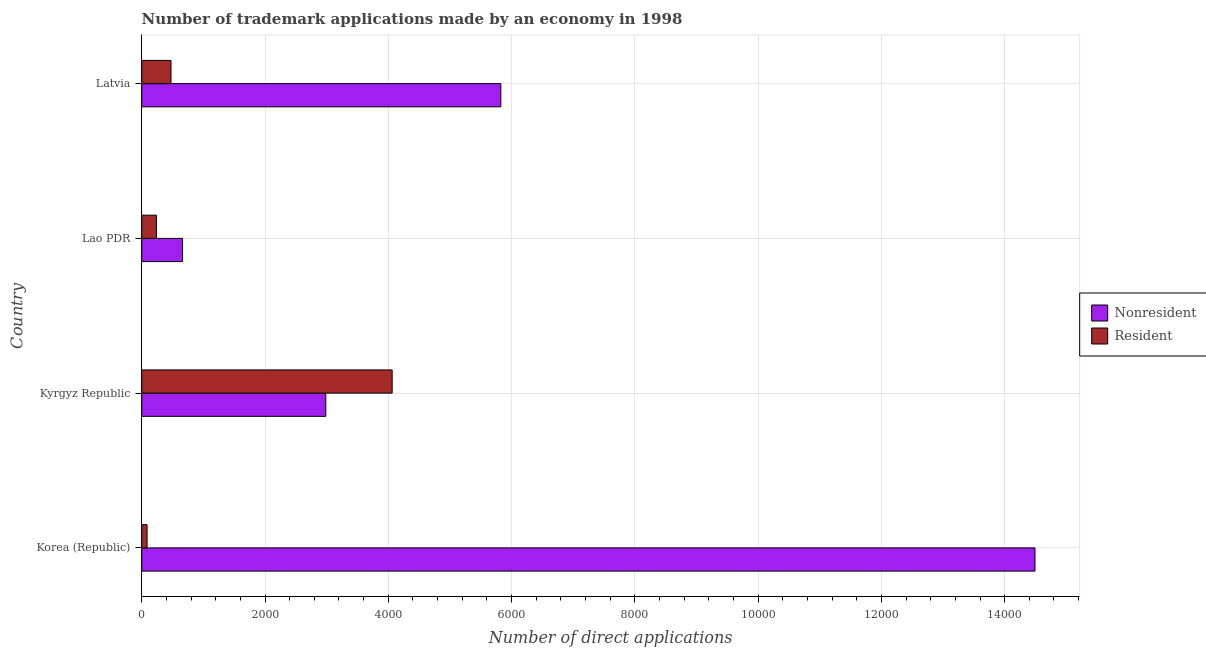How many groups of bars are there?
Offer a very short reply. 4. How many bars are there on the 1st tick from the bottom?
Give a very brief answer. 2. What is the label of the 2nd group of bars from the top?
Your answer should be compact. Lao PDR. In how many cases, is the number of bars for a given country not equal to the number of legend labels?
Make the answer very short. 0. What is the number of trademark applications made by residents in Lao PDR?
Offer a very short reply. 239. Across all countries, what is the maximum number of trademark applications made by residents?
Your answer should be compact. 4063. Across all countries, what is the minimum number of trademark applications made by non residents?
Give a very brief answer. 662. In which country was the number of trademark applications made by residents maximum?
Your response must be concise. Kyrgyz Republic. What is the total number of trademark applications made by residents in the graph?
Offer a terse response. 4864. What is the difference between the number of trademark applications made by non residents in Lao PDR and that in Latvia?
Your answer should be compact. -5164. What is the difference between the number of trademark applications made by residents in Latvia and the number of trademark applications made by non residents in Korea (Republic)?
Offer a very short reply. -1.40e+04. What is the average number of trademark applications made by residents per country?
Keep it short and to the point. 1216. What is the difference between the number of trademark applications made by non residents and number of trademark applications made by residents in Latvia?
Provide a short and direct response. 5351. In how many countries, is the number of trademark applications made by non residents greater than 9200 ?
Your answer should be very brief. 1. What is the ratio of the number of trademark applications made by non residents in Korea (Republic) to that in Latvia?
Your response must be concise. 2.49. What is the difference between the highest and the second highest number of trademark applications made by non residents?
Keep it short and to the point. 8666. What is the difference between the highest and the lowest number of trademark applications made by non residents?
Offer a terse response. 1.38e+04. In how many countries, is the number of trademark applications made by non residents greater than the average number of trademark applications made by non residents taken over all countries?
Make the answer very short. 1. Is the sum of the number of trademark applications made by non residents in Korea (Republic) and Kyrgyz Republic greater than the maximum number of trademark applications made by residents across all countries?
Provide a succinct answer. Yes. What does the 2nd bar from the top in Korea (Republic) represents?
Provide a short and direct response. Nonresident. What does the 1st bar from the bottom in Kyrgyz Republic represents?
Provide a short and direct response. Nonresident. How many bars are there?
Give a very brief answer. 8. How many countries are there in the graph?
Give a very brief answer. 4. What is the difference between two consecutive major ticks on the X-axis?
Your answer should be very brief. 2000. Are the values on the major ticks of X-axis written in scientific E-notation?
Offer a terse response. No. Where does the legend appear in the graph?
Offer a terse response. Center right. How are the legend labels stacked?
Your response must be concise. Vertical. What is the title of the graph?
Your answer should be compact. Number of trademark applications made by an economy in 1998. What is the label or title of the X-axis?
Give a very brief answer. Number of direct applications. What is the Number of direct applications of Nonresident in Korea (Republic)?
Your answer should be compact. 1.45e+04. What is the Number of direct applications in Resident in Korea (Republic)?
Your answer should be very brief. 87. What is the Number of direct applications of Nonresident in Kyrgyz Republic?
Provide a short and direct response. 2986. What is the Number of direct applications of Resident in Kyrgyz Republic?
Offer a terse response. 4063. What is the Number of direct applications of Nonresident in Lao PDR?
Offer a very short reply. 662. What is the Number of direct applications in Resident in Lao PDR?
Give a very brief answer. 239. What is the Number of direct applications of Nonresident in Latvia?
Provide a short and direct response. 5826. What is the Number of direct applications in Resident in Latvia?
Provide a short and direct response. 475. Across all countries, what is the maximum Number of direct applications in Nonresident?
Ensure brevity in your answer.  1.45e+04. Across all countries, what is the maximum Number of direct applications in Resident?
Ensure brevity in your answer.  4063. Across all countries, what is the minimum Number of direct applications in Nonresident?
Your answer should be compact. 662. Across all countries, what is the minimum Number of direct applications of Resident?
Keep it short and to the point. 87. What is the total Number of direct applications of Nonresident in the graph?
Give a very brief answer. 2.40e+04. What is the total Number of direct applications in Resident in the graph?
Give a very brief answer. 4864. What is the difference between the Number of direct applications of Nonresident in Korea (Republic) and that in Kyrgyz Republic?
Offer a terse response. 1.15e+04. What is the difference between the Number of direct applications in Resident in Korea (Republic) and that in Kyrgyz Republic?
Your answer should be compact. -3976. What is the difference between the Number of direct applications of Nonresident in Korea (Republic) and that in Lao PDR?
Provide a succinct answer. 1.38e+04. What is the difference between the Number of direct applications in Resident in Korea (Republic) and that in Lao PDR?
Keep it short and to the point. -152. What is the difference between the Number of direct applications in Nonresident in Korea (Republic) and that in Latvia?
Ensure brevity in your answer.  8666. What is the difference between the Number of direct applications of Resident in Korea (Republic) and that in Latvia?
Your answer should be compact. -388. What is the difference between the Number of direct applications in Nonresident in Kyrgyz Republic and that in Lao PDR?
Give a very brief answer. 2324. What is the difference between the Number of direct applications of Resident in Kyrgyz Republic and that in Lao PDR?
Your response must be concise. 3824. What is the difference between the Number of direct applications of Nonresident in Kyrgyz Republic and that in Latvia?
Give a very brief answer. -2840. What is the difference between the Number of direct applications of Resident in Kyrgyz Republic and that in Latvia?
Make the answer very short. 3588. What is the difference between the Number of direct applications of Nonresident in Lao PDR and that in Latvia?
Offer a very short reply. -5164. What is the difference between the Number of direct applications of Resident in Lao PDR and that in Latvia?
Your answer should be very brief. -236. What is the difference between the Number of direct applications in Nonresident in Korea (Republic) and the Number of direct applications in Resident in Kyrgyz Republic?
Keep it short and to the point. 1.04e+04. What is the difference between the Number of direct applications in Nonresident in Korea (Republic) and the Number of direct applications in Resident in Lao PDR?
Ensure brevity in your answer.  1.43e+04. What is the difference between the Number of direct applications in Nonresident in Korea (Republic) and the Number of direct applications in Resident in Latvia?
Keep it short and to the point. 1.40e+04. What is the difference between the Number of direct applications in Nonresident in Kyrgyz Republic and the Number of direct applications in Resident in Lao PDR?
Offer a very short reply. 2747. What is the difference between the Number of direct applications in Nonresident in Kyrgyz Republic and the Number of direct applications in Resident in Latvia?
Your answer should be compact. 2511. What is the difference between the Number of direct applications of Nonresident in Lao PDR and the Number of direct applications of Resident in Latvia?
Provide a short and direct response. 187. What is the average Number of direct applications of Nonresident per country?
Your answer should be very brief. 5991.5. What is the average Number of direct applications of Resident per country?
Your answer should be very brief. 1216. What is the difference between the Number of direct applications of Nonresident and Number of direct applications of Resident in Korea (Republic)?
Offer a very short reply. 1.44e+04. What is the difference between the Number of direct applications of Nonresident and Number of direct applications of Resident in Kyrgyz Republic?
Keep it short and to the point. -1077. What is the difference between the Number of direct applications in Nonresident and Number of direct applications in Resident in Lao PDR?
Make the answer very short. 423. What is the difference between the Number of direct applications of Nonresident and Number of direct applications of Resident in Latvia?
Ensure brevity in your answer.  5351. What is the ratio of the Number of direct applications of Nonresident in Korea (Republic) to that in Kyrgyz Republic?
Make the answer very short. 4.85. What is the ratio of the Number of direct applications of Resident in Korea (Republic) to that in Kyrgyz Republic?
Offer a very short reply. 0.02. What is the ratio of the Number of direct applications in Nonresident in Korea (Republic) to that in Lao PDR?
Provide a short and direct response. 21.89. What is the ratio of the Number of direct applications in Resident in Korea (Republic) to that in Lao PDR?
Provide a succinct answer. 0.36. What is the ratio of the Number of direct applications in Nonresident in Korea (Republic) to that in Latvia?
Your response must be concise. 2.49. What is the ratio of the Number of direct applications of Resident in Korea (Republic) to that in Latvia?
Provide a short and direct response. 0.18. What is the ratio of the Number of direct applications of Nonresident in Kyrgyz Republic to that in Lao PDR?
Make the answer very short. 4.51. What is the ratio of the Number of direct applications of Resident in Kyrgyz Republic to that in Lao PDR?
Provide a succinct answer. 17. What is the ratio of the Number of direct applications in Nonresident in Kyrgyz Republic to that in Latvia?
Your answer should be very brief. 0.51. What is the ratio of the Number of direct applications in Resident in Kyrgyz Republic to that in Latvia?
Your answer should be very brief. 8.55. What is the ratio of the Number of direct applications of Nonresident in Lao PDR to that in Latvia?
Your response must be concise. 0.11. What is the ratio of the Number of direct applications of Resident in Lao PDR to that in Latvia?
Ensure brevity in your answer.  0.5. What is the difference between the highest and the second highest Number of direct applications of Nonresident?
Provide a succinct answer. 8666. What is the difference between the highest and the second highest Number of direct applications in Resident?
Make the answer very short. 3588. What is the difference between the highest and the lowest Number of direct applications of Nonresident?
Provide a succinct answer. 1.38e+04. What is the difference between the highest and the lowest Number of direct applications of Resident?
Provide a succinct answer. 3976. 